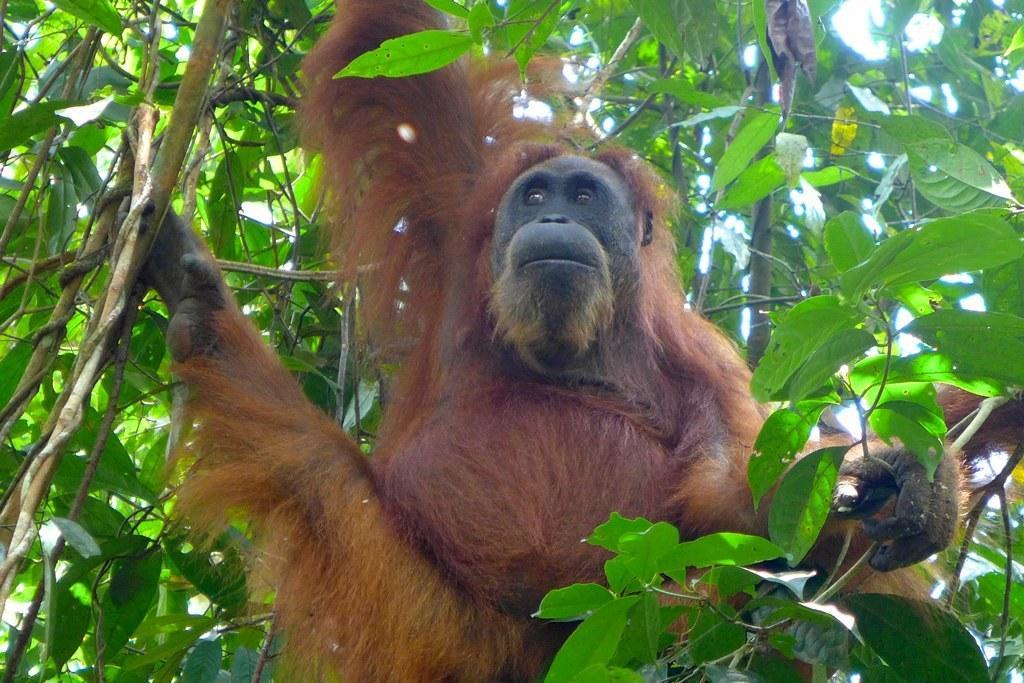In one or two sentences, can you explain what this image depicts? In this picture we can see a chimpanzee in the front, there is a tree in the middle, we can see the sky in the background. 